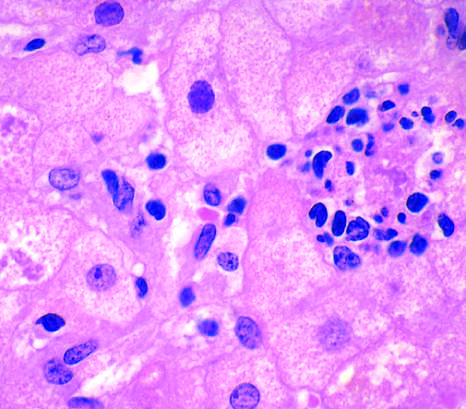how is hepatocyte injury in fatty liver disease associated?
Answer the question using a single word or phrase. With chronic alcohol use 